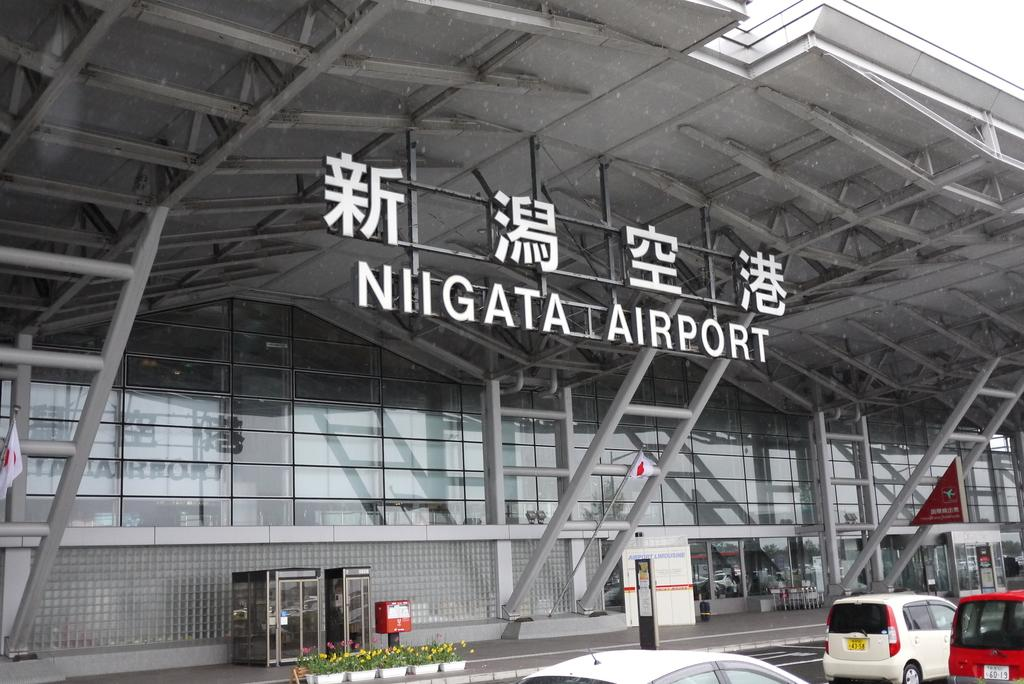What can be seen on the road in the image? There are vehicles on the road in the image. What type of building is visible in the background? There is a glass building in the background of the image. What color are the poles in the image? The poles in the image are gray-colored. What type of soda is being advertised on the glass building in the image? There is no soda being advertised on the glass building in the image; it is a glass building without any advertisements. How many windows are visible on the glass building in the image? There are no windows visible on the glass building in the image; it is a solid glass structure. 